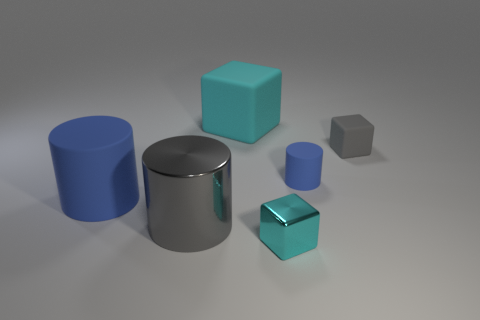The small blue rubber thing has what shape?
Offer a terse response. Cylinder. What number of small objects are metal objects or yellow metallic spheres?
Offer a very short reply. 1. What size is the gray matte object that is the same shape as the cyan metallic thing?
Provide a short and direct response. Small. What number of objects are both behind the large metallic object and on the right side of the metallic cylinder?
Your answer should be compact. 3. There is a small cyan object; is its shape the same as the matte object that is on the left side of the large matte cube?
Provide a short and direct response. No. Are there more tiny gray blocks on the right side of the gray matte thing than tiny cyan blocks?
Ensure brevity in your answer.  No. Is the number of big matte objects that are to the right of the small gray cube less than the number of small yellow rubber balls?
Offer a terse response. No. What number of other tiny metal things are the same color as the tiny metallic thing?
Provide a short and direct response. 0. There is a cube that is behind the gray metal cylinder and on the left side of the tiny blue cylinder; what material is it?
Your answer should be compact. Rubber. There is a matte thing left of the large cyan cube; does it have the same color as the small rubber cylinder that is to the right of the large cyan matte cube?
Keep it short and to the point. Yes. 